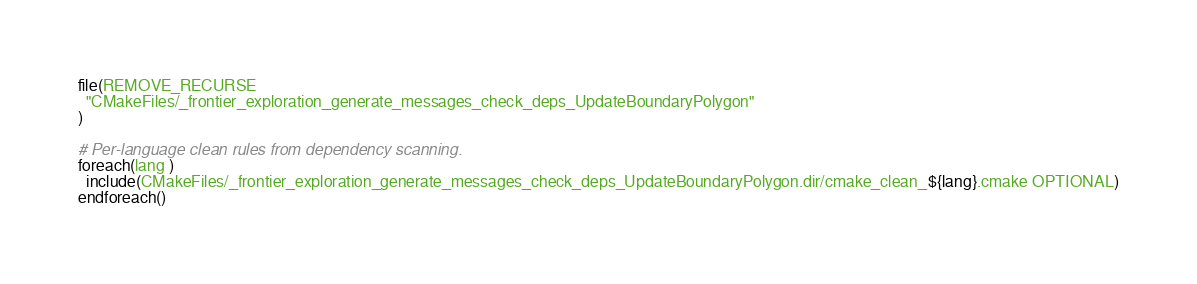<code> <loc_0><loc_0><loc_500><loc_500><_CMake_>file(REMOVE_RECURSE
  "CMakeFiles/_frontier_exploration_generate_messages_check_deps_UpdateBoundaryPolygon"
)

# Per-language clean rules from dependency scanning.
foreach(lang )
  include(CMakeFiles/_frontier_exploration_generate_messages_check_deps_UpdateBoundaryPolygon.dir/cmake_clean_${lang}.cmake OPTIONAL)
endforeach()
</code> 